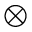<formula> <loc_0><loc_0><loc_500><loc_500>\otimes</formula> 